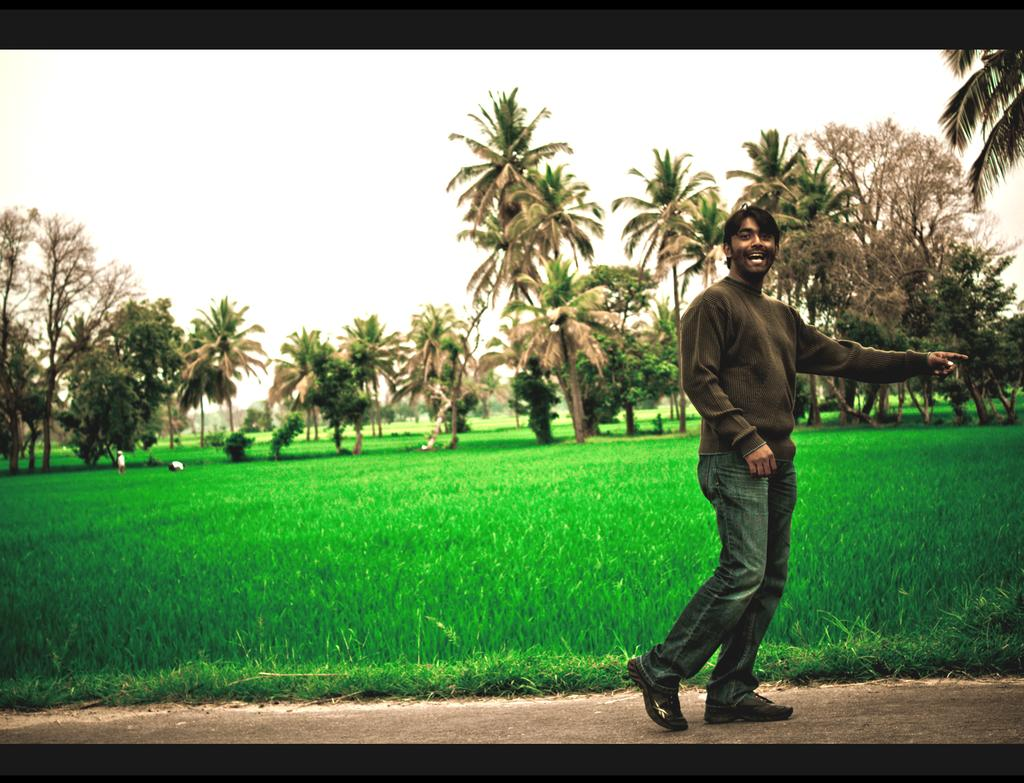What is the man in the image doing? The man is walking in the image. Where is the man walking? The man is walking on a path. What can be seen in the background of the image? There is grass, trees, and the sky visible in the image. How is the image framed? The image has two black borders. What is the man arguing about in the image? There is no indication of an argument in the image; the man is simply walking on a path. What answer does the man provide in the image? There is no question or answer being exchanged in the image; the man is just walking. 